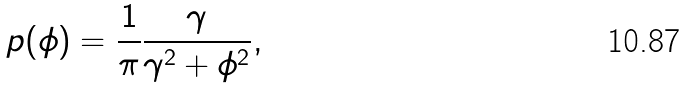Convert formula to latex. <formula><loc_0><loc_0><loc_500><loc_500>p ( \phi ) = \frac { 1 } { \pi } \frac { \gamma } { \gamma ^ { 2 } + \phi ^ { 2 } } ,</formula> 